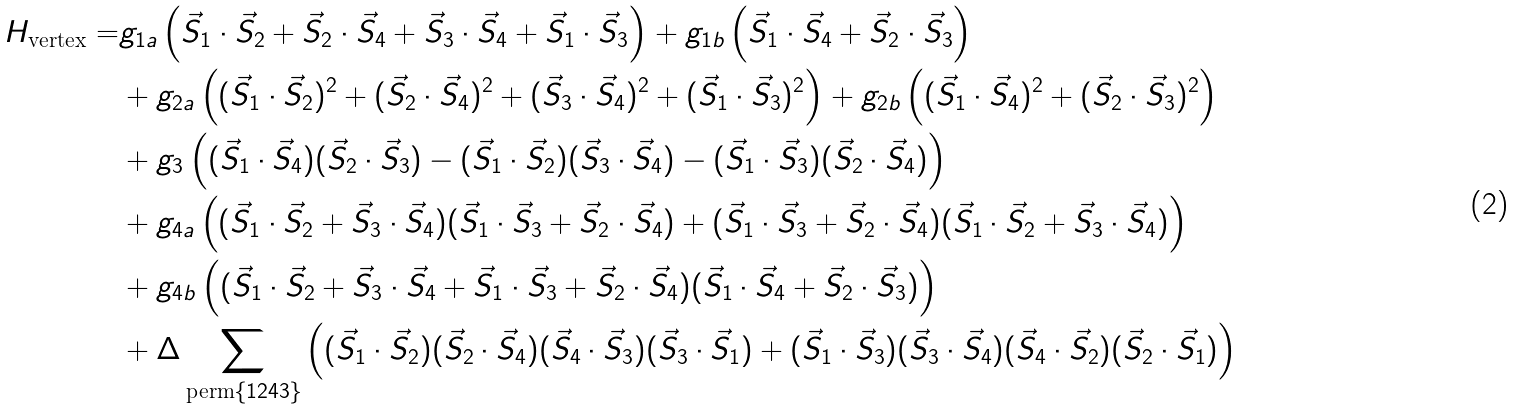Convert formula to latex. <formula><loc_0><loc_0><loc_500><loc_500>H _ { \text {vertex} } = & g _ { 1 a } \left ( \vec { S } _ { 1 } \cdot \vec { S } _ { 2 } + \vec { S } _ { 2 } \cdot \vec { S } _ { 4 } + \vec { S } _ { 3 } \cdot \vec { S } _ { 4 } + \vec { S } _ { 1 } \cdot \vec { S } _ { 3 } \right ) + g _ { 1 b } \left ( \vec { S } _ { 1 } \cdot \vec { S } _ { 4 } + \vec { S } _ { 2 } \cdot \vec { S } _ { 3 } \right ) \\ & + g _ { 2 a } \left ( ( \vec { S } _ { 1 } \cdot \vec { S } _ { 2 } ) ^ { 2 } + ( \vec { S } _ { 2 } \cdot \vec { S } _ { 4 } ) ^ { 2 } + ( \vec { S } _ { 3 } \cdot \vec { S } _ { 4 } ) ^ { 2 } + ( \vec { S } _ { 1 } \cdot \vec { S } _ { 3 } ) ^ { 2 } \right ) + g _ { 2 b } \left ( ( \vec { S } _ { 1 } \cdot \vec { S } _ { 4 } ) ^ { 2 } + ( \vec { S } _ { 2 } \cdot \vec { S } _ { 3 } ) ^ { 2 } \right ) \\ & + g _ { 3 } \left ( ( \vec { S } _ { 1 } \cdot \vec { S } _ { 4 } ) ( \vec { S } _ { 2 } \cdot \vec { S } _ { 3 } ) - ( \vec { S } _ { 1 } \cdot \vec { S } _ { 2 } ) ( \vec { S } _ { 3 } \cdot \vec { S } _ { 4 } ) - ( \vec { S } _ { 1 } \cdot \vec { S } _ { 3 } ) ( \vec { S } _ { 2 } \cdot \vec { S } _ { 4 } ) \right ) \\ & + g _ { 4 a } \left ( ( \vec { S } _ { 1 } \cdot \vec { S } _ { 2 } + \vec { S } _ { 3 } \cdot \vec { S } _ { 4 } ) ( \vec { S } _ { 1 } \cdot \vec { S } _ { 3 } + \vec { S } _ { 2 } \cdot \vec { S } _ { 4 } ) + ( \vec { S } _ { 1 } \cdot \vec { S } _ { 3 } + \vec { S } _ { 2 } \cdot \vec { S } _ { 4 } ) ( \vec { S } _ { 1 } \cdot \vec { S } _ { 2 } + \vec { S } _ { 3 } \cdot \vec { S } _ { 4 } ) \right ) \\ & + g _ { 4 b } \left ( ( \vec { S } _ { 1 } \cdot \vec { S } _ { 2 } + \vec { S } _ { 3 } \cdot \vec { S } _ { 4 } + \vec { S } _ { 1 } \cdot \vec { S } _ { 3 } + \vec { S } _ { 2 } \cdot \vec { S } _ { 4 } ) ( \vec { S } _ { 1 } \cdot \vec { S } _ { 4 } + \vec { S } _ { 2 } \cdot \vec { S } _ { 3 } ) \right ) \\ & + \Delta \sum _ { \text {perm} \{ 1 2 4 3 \} } \left ( ( \vec { S } _ { 1 } \cdot \vec { S } _ { 2 } ) ( \vec { S } _ { 2 } \cdot \vec { S } _ { 4 } ) ( \vec { S } _ { 4 } \cdot \vec { S } _ { 3 } ) ( \vec { S } _ { 3 } \cdot \vec { S } _ { 1 } ) + ( \vec { S } _ { 1 } \cdot \vec { S } _ { 3 } ) ( \vec { S } _ { 3 } \cdot \vec { S } _ { 4 } ) ( \vec { S } _ { 4 } \cdot \vec { S } _ { 2 } ) ( \vec { S } _ { 2 } \cdot \vec { S } _ { 1 } ) \right )</formula> 